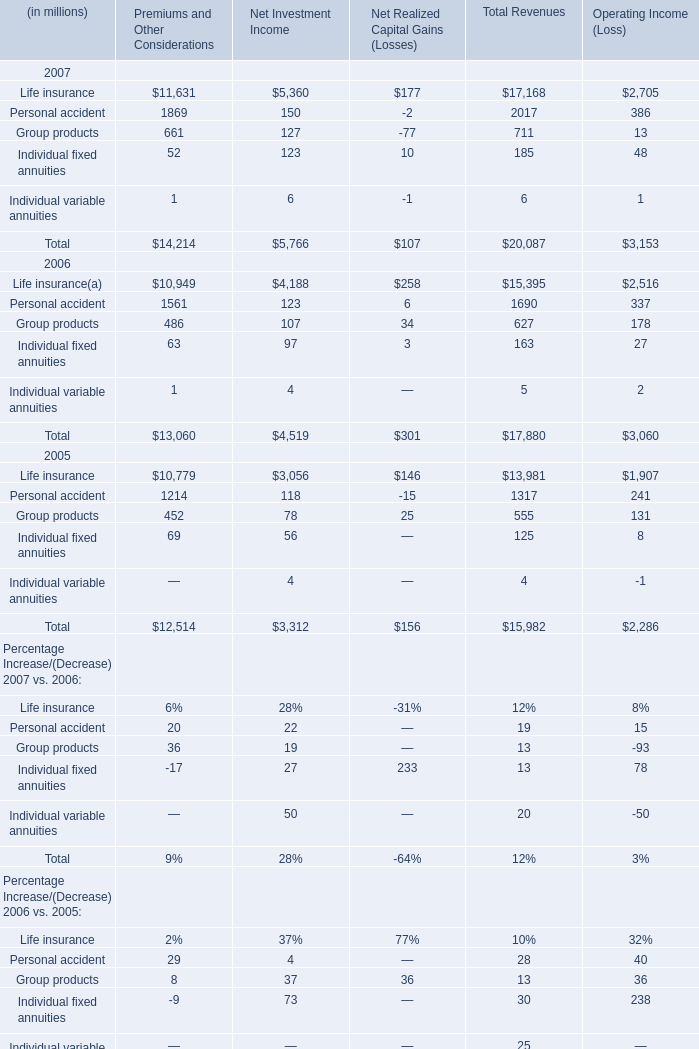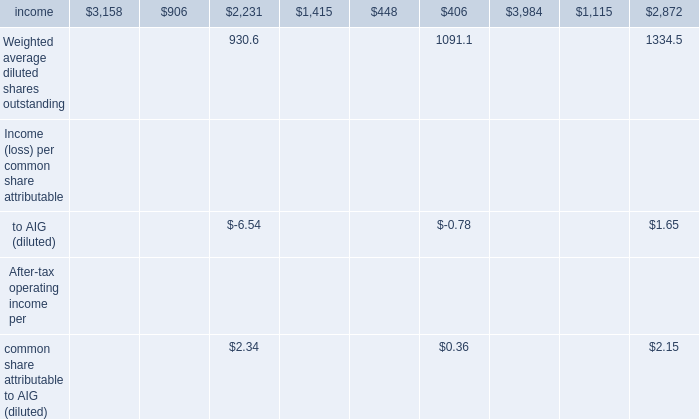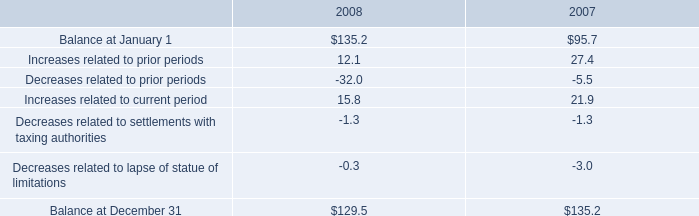In the year with the most Life insurance of Premiums and Other Considerations, what is the growth rate of Group products of Premiums and Other Considerations? 
Computations: ((661 - 486) / 486)
Answer: 0.36008. 